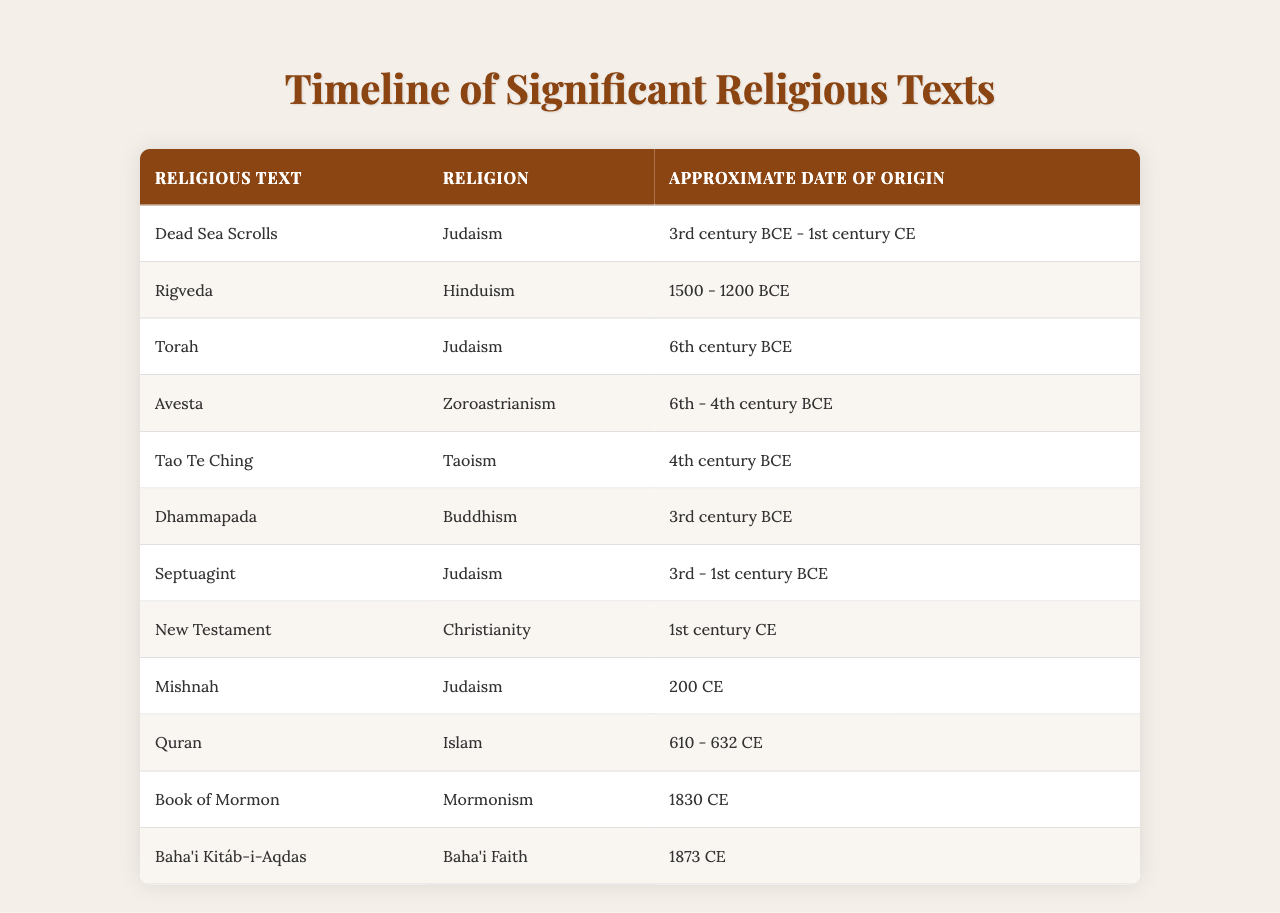What is the religion associated with the Quran? The table lists the Quran under the category of Islam in the Religion column.
Answer: Islam Which religious text is oldest according to the table? The Rigveda has the earliest approximate date of origin listed, which is between 1500 and 1200 BCE.
Answer: Rigveda How many religious texts originate from Judaism? By reviewing the Religion column, we see that the Torah, Dead Sea Scrolls, Septuagint, and Mishnah all indicate Judaism, which totals four texts.
Answer: 4 What is the approximate date of origin for the Dhammapada? The table states that the Dhammapada originates around the 3rd century BCE in the Date column.
Answer: 3rd century BCE Is the Book of Mormon older than the Tao Te Ching? By comparing the dates, the Book of Mormon originates in 1830 CE, which is later than the 4th century BCE for the Tao Te Ching, confirming that the Tao Te Ching is older.
Answer: Yes What is the average date range of origin for Zoroastrian religious texts based on the table? The only Zoroastrian text listed is the Avesta, which is from the 6th to 4th century BCE. Since there's only one text, the average is the same as its range, which is 6th - 4th century BCE.
Answer: 6th - 4th century BCE How many religious texts were created in the 1st century CE? The New Testament is the only text associated with the 1st century CE according to the table.
Answer: 1 Are there any texts listed with approximate dates from the 3rd century CE? After reviewing the Approximate Date of Origin column, there are no texts listed from the 3rd century CE, indicating none exist in this period.
Answer: No What is the latest religious text mentioned in the table? The Book of Mormon has the most recent date of origin listed as 1830 CE, making it the latest text in the table.
Answer: Book of Mormon Which religious text spans the broadest date range in its origin? The Dead Sea Scrolls, originating from the 3rd century BCE to the 1st century CE, span several centuries which is broader compared to others.
Answer: Dead Sea Scrolls 